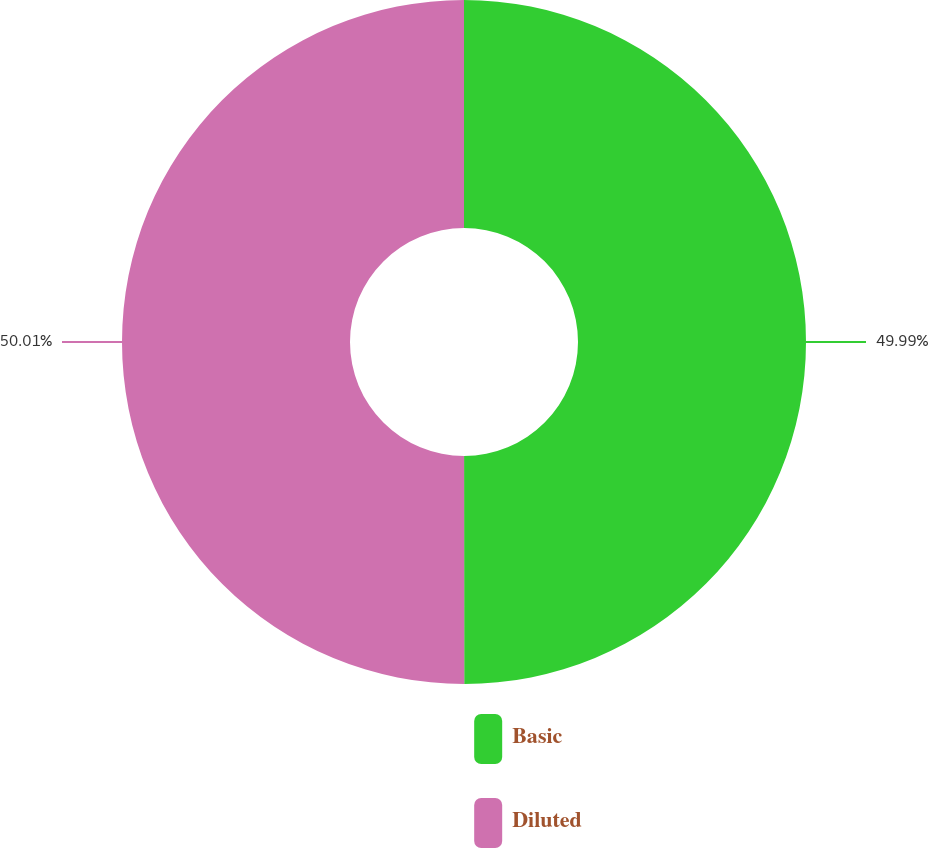Convert chart. <chart><loc_0><loc_0><loc_500><loc_500><pie_chart><fcel>Basic<fcel>Diluted<nl><fcel>49.99%<fcel>50.01%<nl></chart> 